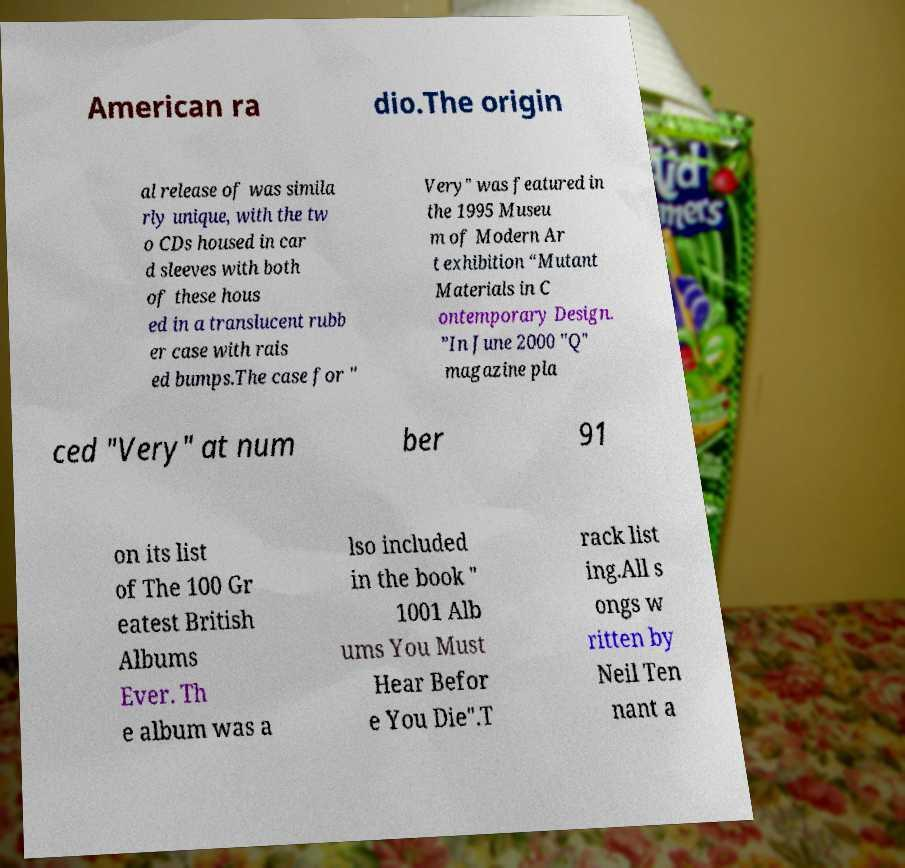Can you read and provide the text displayed in the image?This photo seems to have some interesting text. Can you extract and type it out for me? American ra dio.The origin al release of was simila rly unique, with the tw o CDs housed in car d sleeves with both of these hous ed in a translucent rubb er case with rais ed bumps.The case for " Very" was featured in the 1995 Museu m of Modern Ar t exhibition “Mutant Materials in C ontemporary Design. ”In June 2000 "Q" magazine pla ced "Very" at num ber 91 on its list of The 100 Gr eatest British Albums Ever. Th e album was a lso included in the book " 1001 Alb ums You Must Hear Befor e You Die".T rack list ing.All s ongs w ritten by Neil Ten nant a 